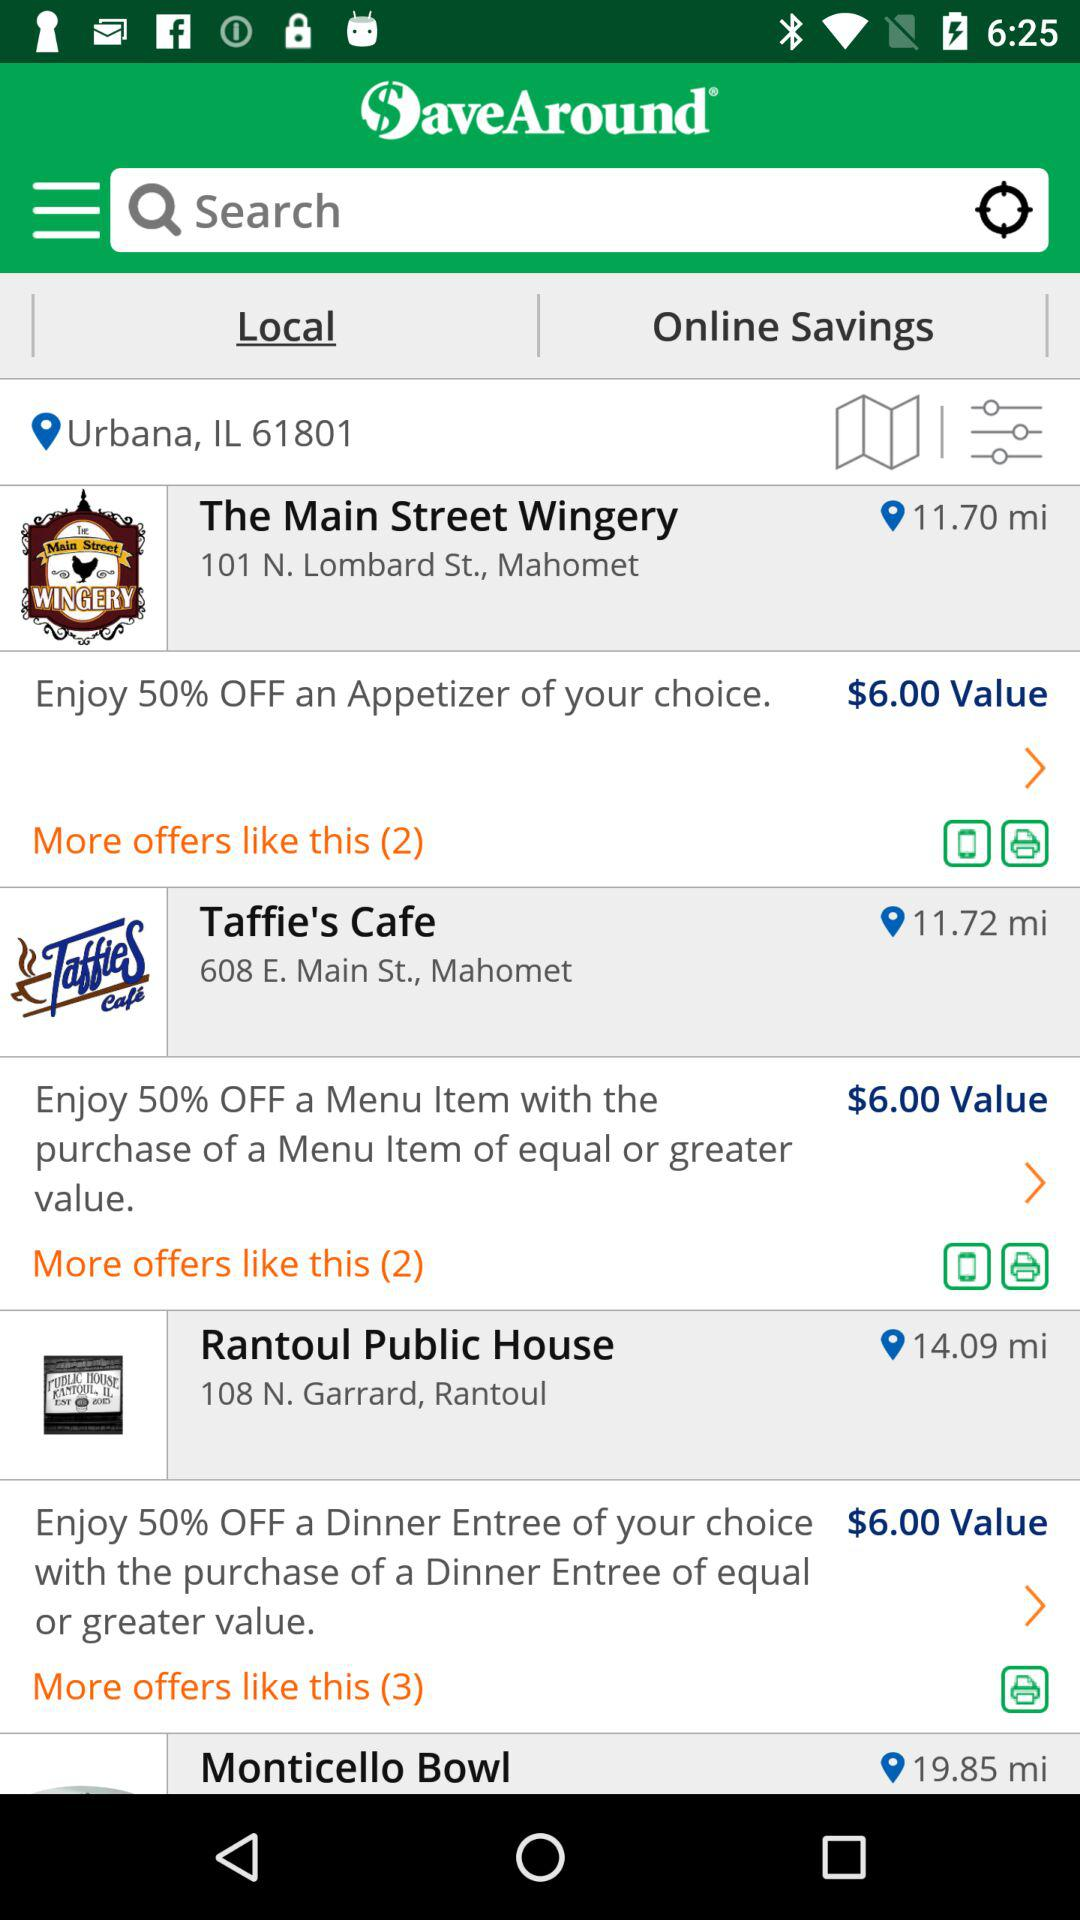How many offers are available for Taffie's Cafe?
Answer the question using a single word or phrase. 2 